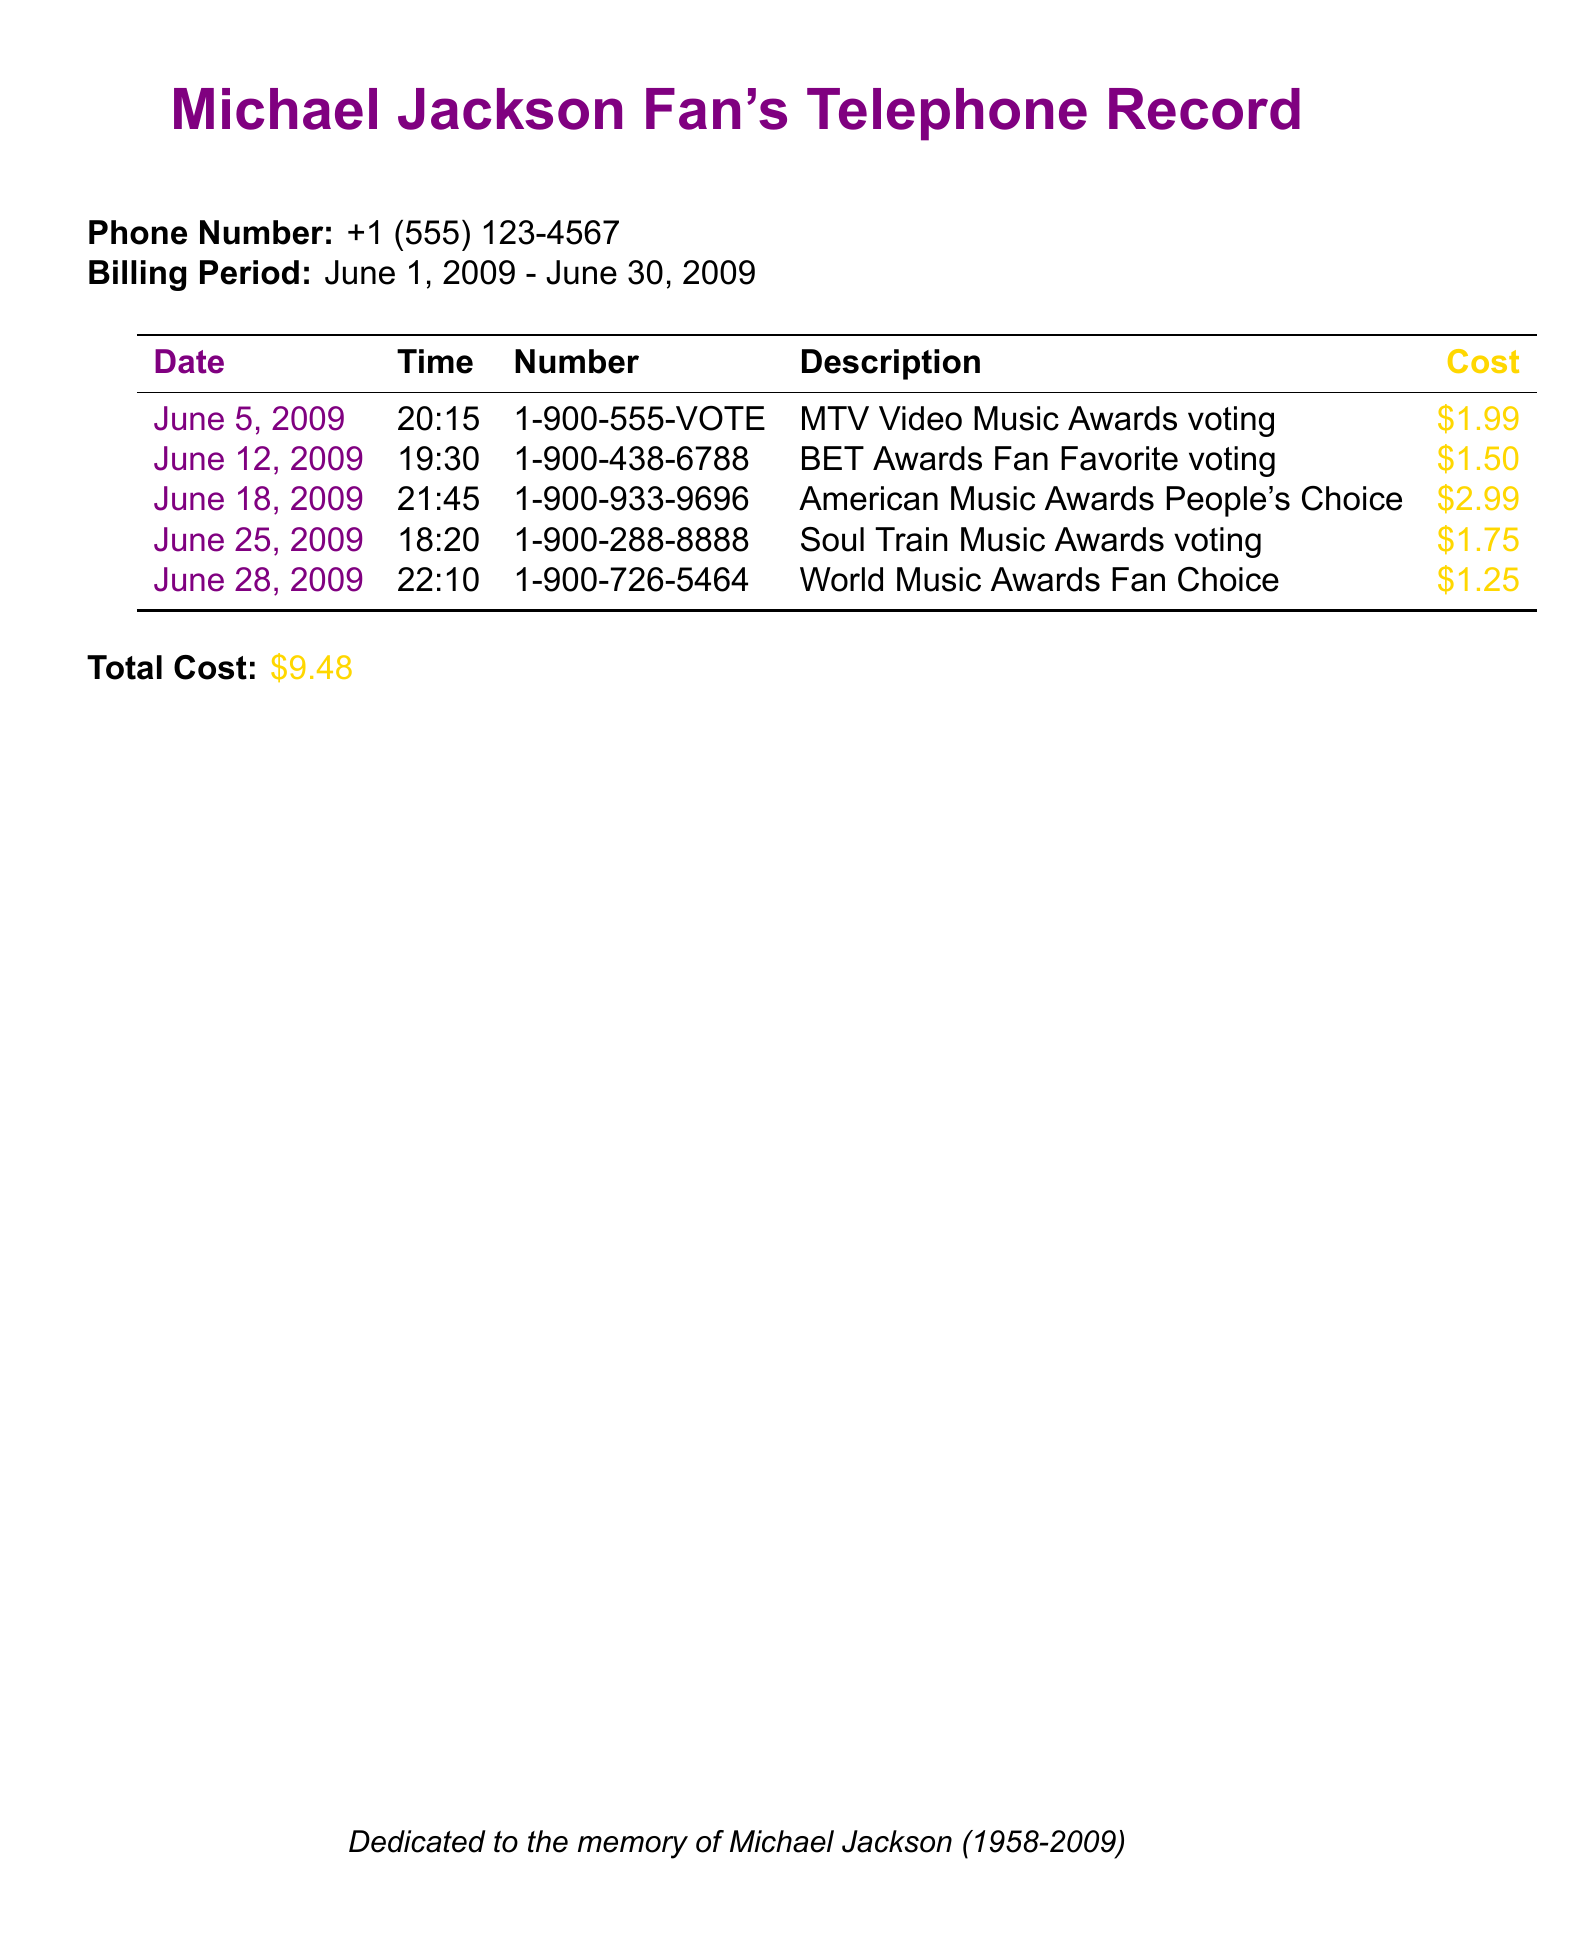What is the phone number? The phone number is presented at the beginning of the document, which is +1 (555) 123-4567.
Answer: +1 (555) 123-4567 What is the total cost of the calls? The total cost is listed at the bottom of the document and is the sum of all individual call costs.
Answer: $9.48 On which date was the most expensive call made? The most expensive call costs $2.99, which is recorded on June 18, 2009.
Answer: June 18, 2009 How many different award shows are represented in the calls? The document lists calls for five different award shows, each represented by a unique entry.
Answer: Five What was the cost for voting in the MTV Video Music Awards? The cost for that specific call is detailed in the table, which is $1.99.
Answer: $1.99 Which award show had the least expensive voting call? The least expensive call recorded in the document is for the World Music Awards at $1.25.
Answer: World Music Awards What is the description of the call made on June 25? The call made on that date is described as "Soul Train Music Awards voting."
Answer: Soul Train Music Awards voting At what time was the call for the BET Awards made? The time of the call for the BET Awards is provided as 19:30 on June 12, 2009.
Answer: 19:30 Which color is used for the total cost section? The total cost section is highlighted with a gold color indicated by the color code in the document.
Answer: Gold 